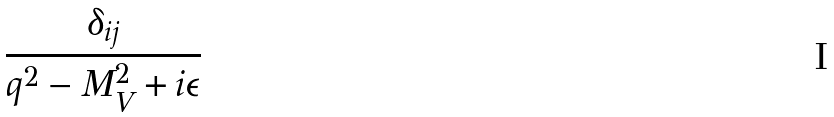<formula> <loc_0><loc_0><loc_500><loc_500>\frac { \delta _ { i j } } { q ^ { 2 } - M ^ { 2 } _ { V } + i \epsilon }</formula> 